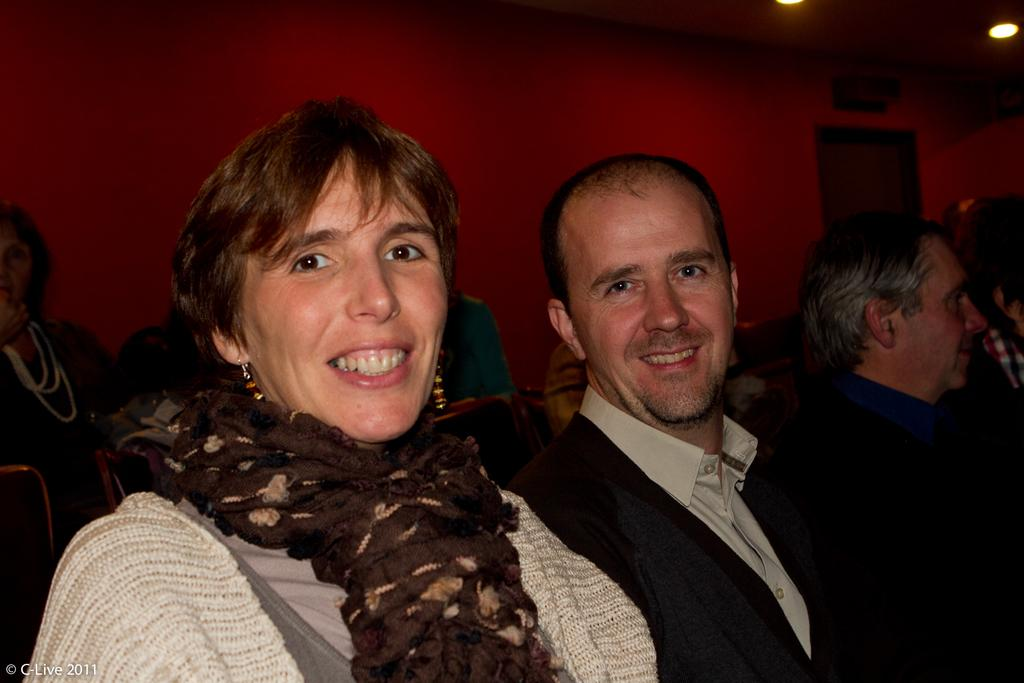How many people are in the image? There are people in the image. Can you describe the two people in the front of the image? A man and a woman are in the front of the image. What expressions do the man and woman have? The man and woman are smiling. What can be seen in the background of the image? There is a wall in the background of the image. What is visible at the top of the image? Lights are visible at the top of the image. What type of sock is the man wearing in the image? There is no sock visible in the image, as the man is not wearing any footwear. What kind of toys can be seen in the hands of the woman in the image? There are no toys present in the image; the woman is not holding any objects. 